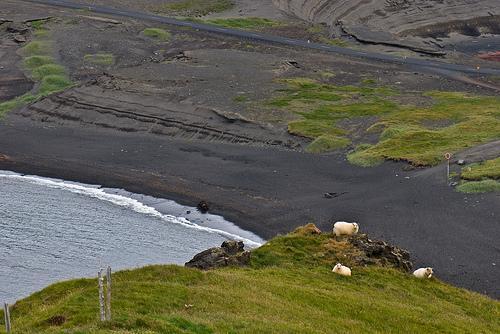How many sheep are in the picture?
Give a very brief answer. 3. How many sheep are standing?
Give a very brief answer. 1. 